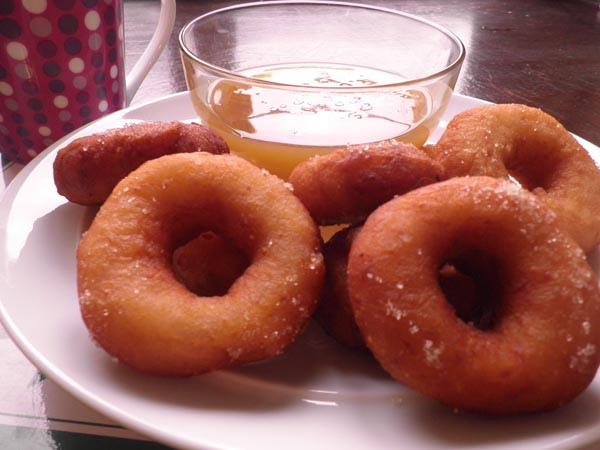What kind of dip is in the bowl?
Give a very brief answer. Honey. How many donuts do you see?
Write a very short answer. 7. How many plates are there?
Concise answer only. 1. How many cups do you see?
Keep it brief. 1. What shape is the pastry?
Give a very brief answer. Round. 